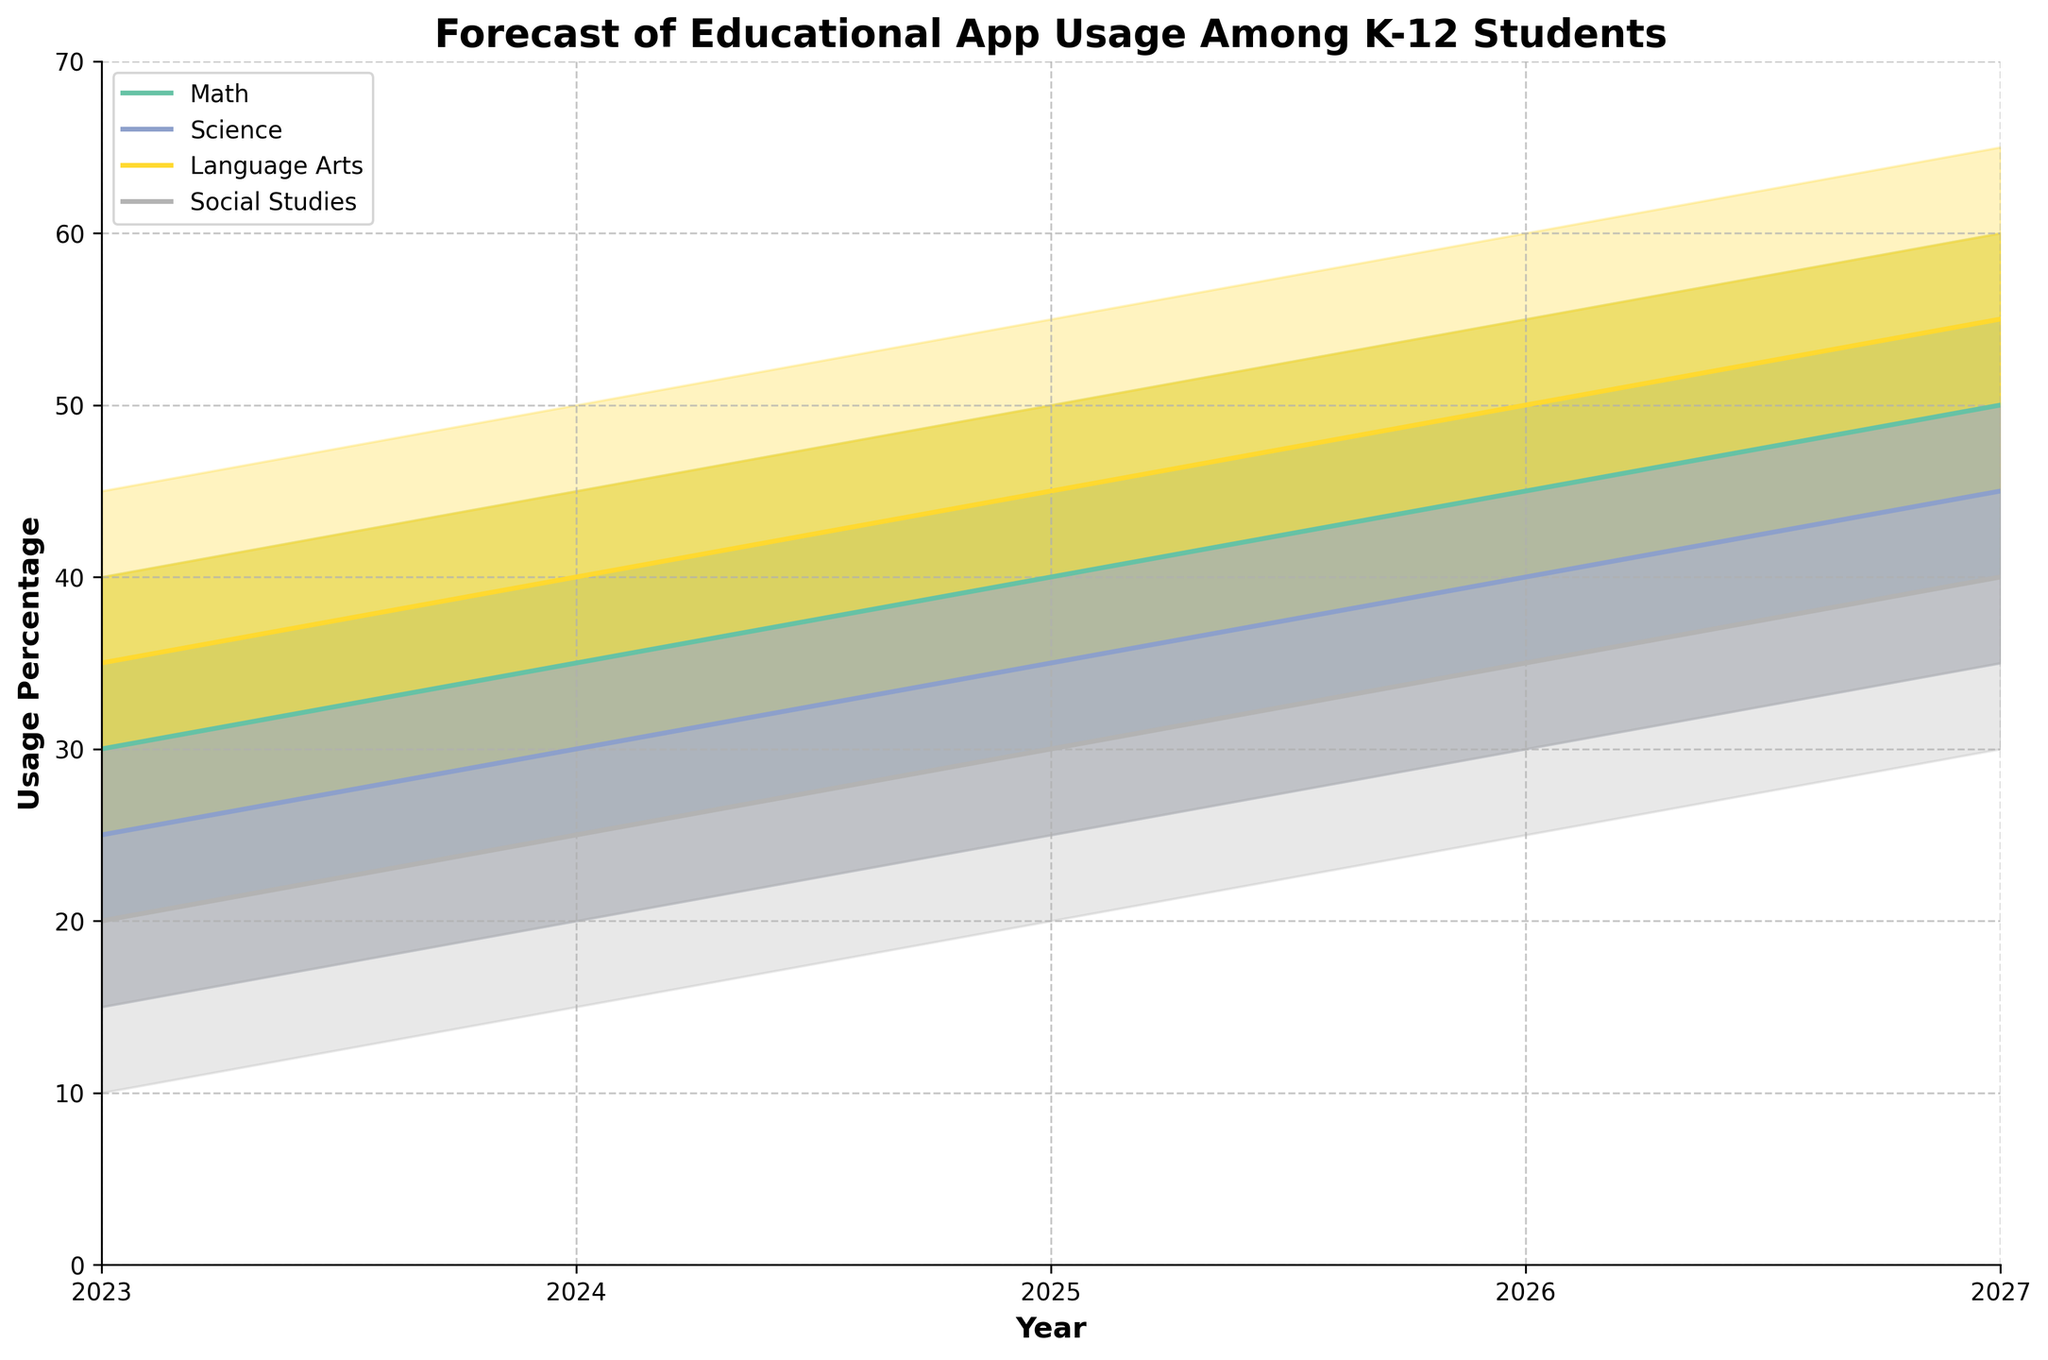How many subject areas are forecasted in the chart? To determine the number of subject areas, look at the legend that lists each subject with a unique color.
Answer: 4 What is the median forecasted usage percentage for Math in 2025? Find Math on the x-axis for the year 2025 and trace up to the line marked with "Median".
Answer: 40 Which subject is forecasted to have the highest median usage percentage in 2027? Compare the "Median" lines for all subjects in 2027 on the x-axis; the highest line indicates the highest forecasted usage percentage.
Answer: Language Arts What is the usage range for Science in 2026? Look at the highest and lowest points of the shaded area for Science in 2026; these show the upper and lower limits of the usage range.
Answer: 30 to 50 For which subject and year is the widest fan (shaded area) observed? Determine which shaded area seems largest by comparing the widths (difference between Upper and Lower bounds) across all subjects and years.
Answer: Language Arts in 2027 Is the forecasted median usage percentage for Social Studies in 2023 higher or lower than the forecasted median for Science in the same year? Compare the median points for Social Studies and Science in 2023.
Answer: Lower What is the difference between the upper and lower forecasted usage percentage for Language Arts in 2024? Subtract the "Lower" value from the "Upper" value for Language Arts in 2024.
Answer: 20 Which subject shows the most consistent usage trend from 2023 to 2027? Look for the line that shows the least fluctuation across the years 2023 to 2027 in the Median forecast.
Answer: Math What is the average of the median forecasted usage percentages for Math over the 5 years? Add the median forecasted usage percentages for Math from 2023 to 2027 and divide by 5. (30+35+40+45+50) / 5 = 40
Answer: 40 Between what percentages is the forecasted usage for Social Studies in 2025 confined? Look at the values of "Lower" and "Upper" for Social Studies in 2025.
Answer: 20 to 40 